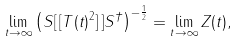<formula> <loc_0><loc_0><loc_500><loc_500>\lim _ { t \rightarrow \infty } \left ( S [ \, [ T ( t ) ^ { 2 } ] \, ] S ^ { \dagger } \right ) ^ { - \frac { 1 } { 2 } } = \lim _ { t \rightarrow \infty } Z ( t ) ,</formula> 